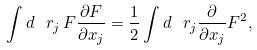Convert formula to latex. <formula><loc_0><loc_0><loc_500><loc_500>\int d \ r _ { j } \, F \frac { \partial F } { \partial x _ { j } } = \frac { 1 } { 2 } \int d \ r _ { j } \frac { \partial } { \partial x _ { j } } F ^ { 2 } ,</formula> 